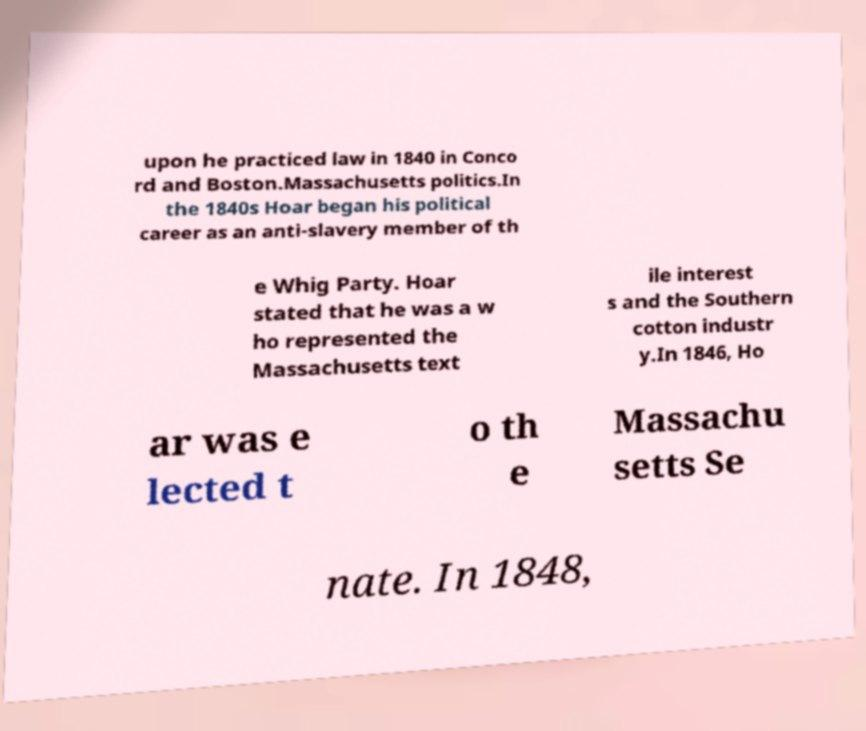There's text embedded in this image that I need extracted. Can you transcribe it verbatim? upon he practiced law in 1840 in Conco rd and Boston.Massachusetts politics.In the 1840s Hoar began his political career as an anti-slavery member of th e Whig Party. Hoar stated that he was a w ho represented the Massachusetts text ile interest s and the Southern cotton industr y.In 1846, Ho ar was e lected t o th e Massachu setts Se nate. In 1848, 